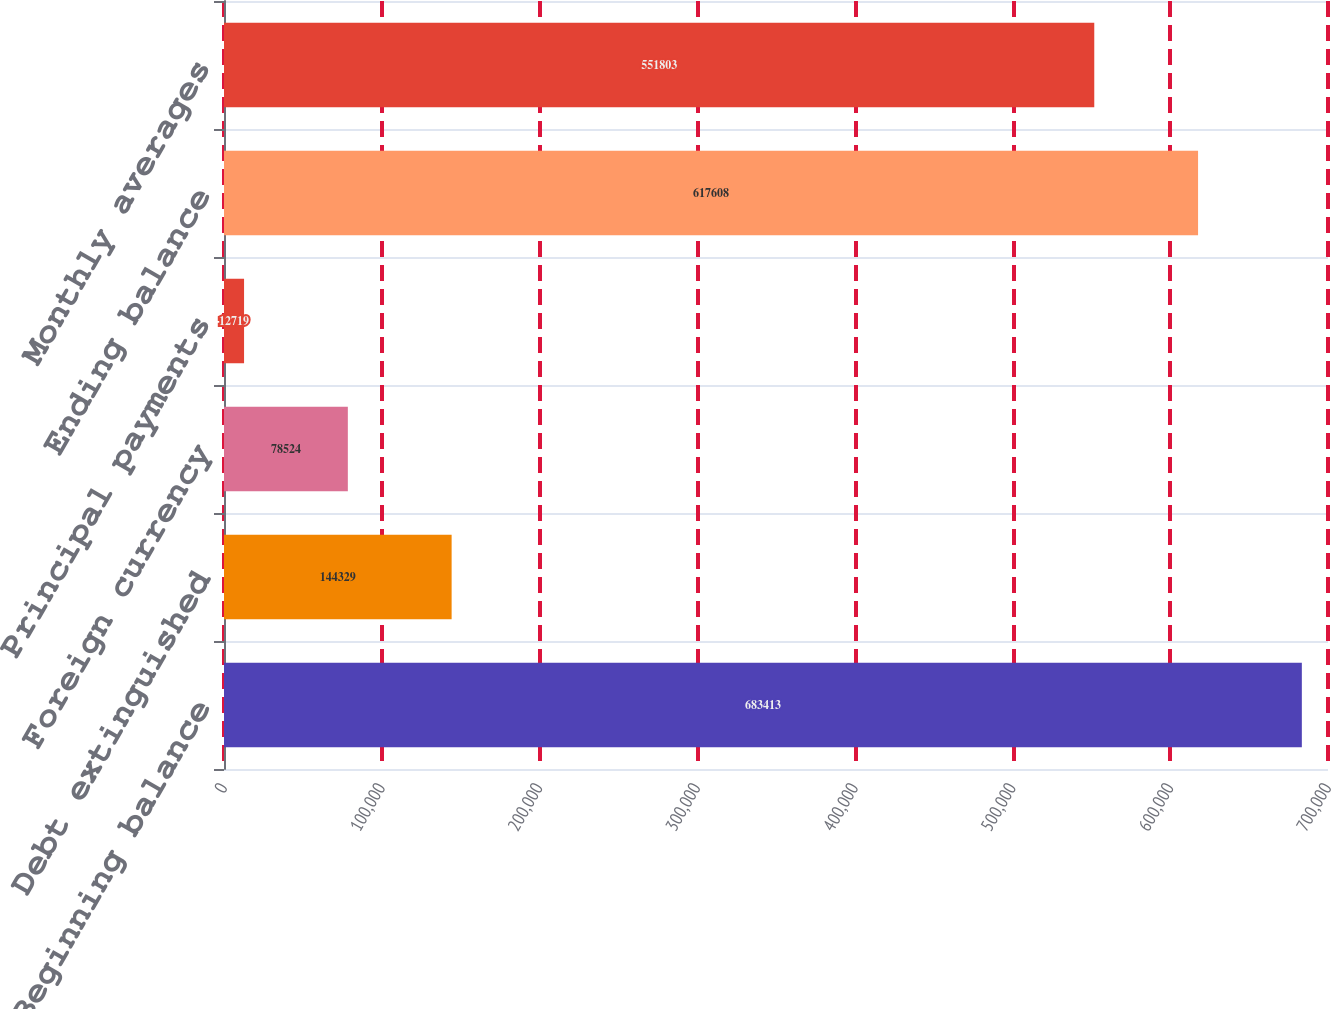Convert chart. <chart><loc_0><loc_0><loc_500><loc_500><bar_chart><fcel>Beginning balance<fcel>Debt extinguished<fcel>Foreign currency<fcel>Principal payments<fcel>Ending balance<fcel>Monthly averages<nl><fcel>683413<fcel>144329<fcel>78524<fcel>12719<fcel>617608<fcel>551803<nl></chart> 